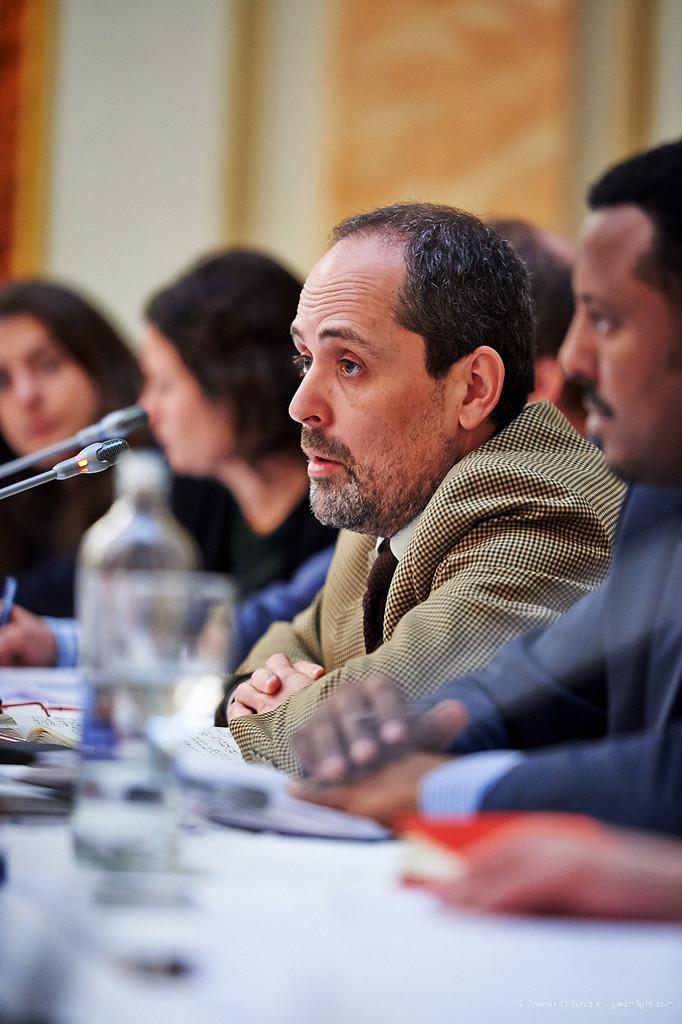In one or two sentences, can you explain what this image depicts? In this picture, we see three men and two women are sitting on the chairs. In front of them, we see a table on which water bottle, glass, papers and a red color book are placed. In front of them, we see the microphones. We see the man in the blazer might be talking on the microphone. In the background, we see a wall in white and orange color. This picture is blurred in the background. 